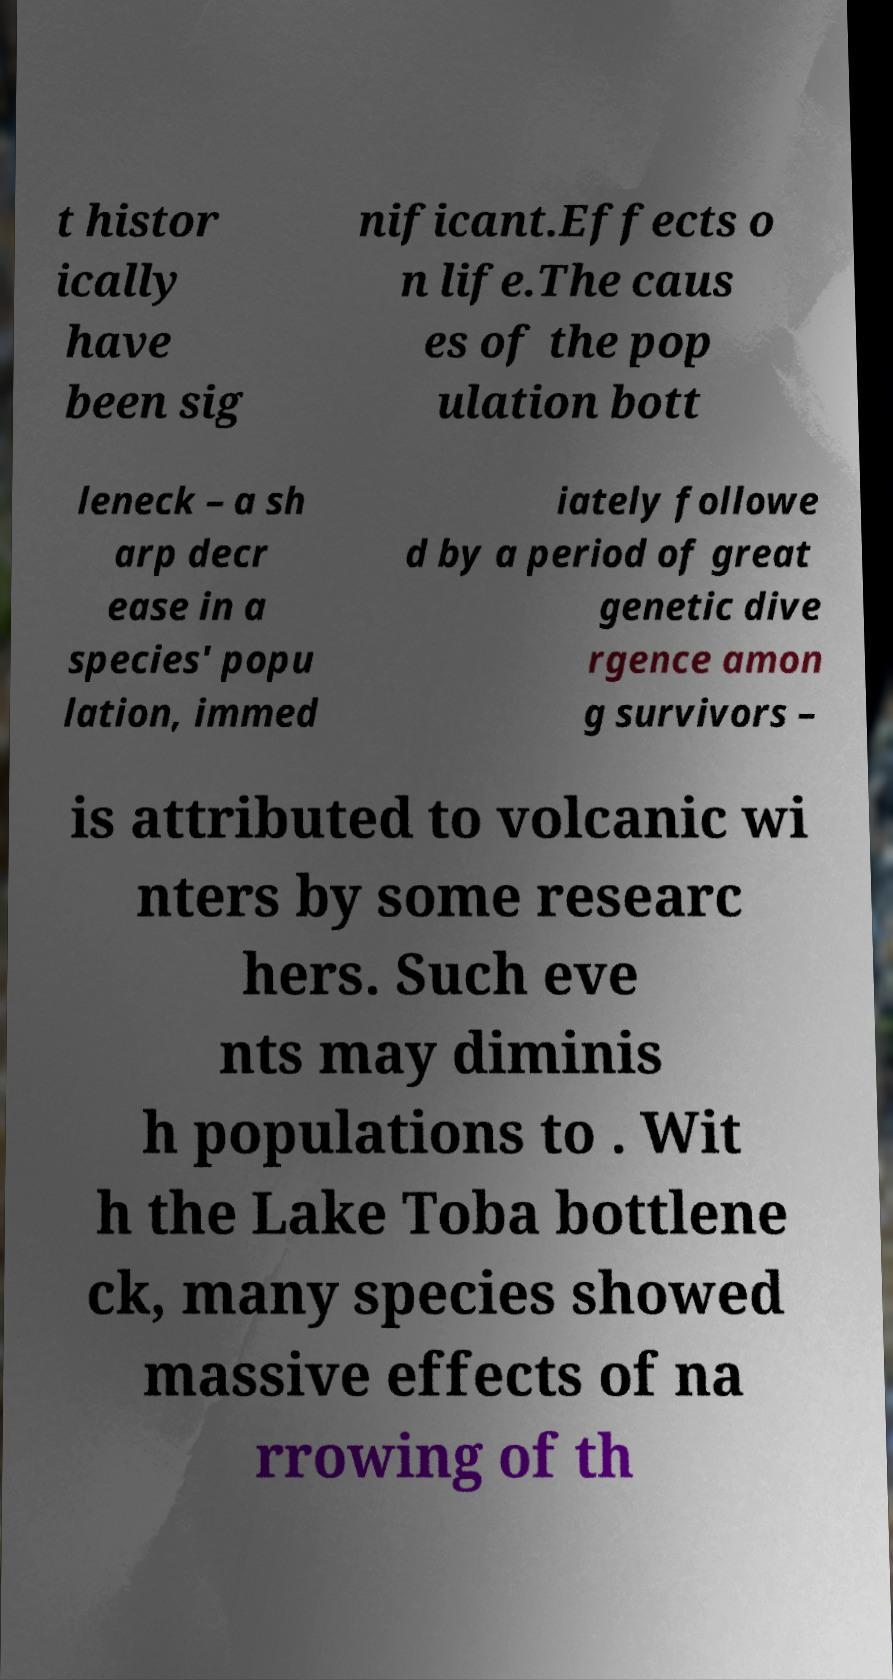For documentation purposes, I need the text within this image transcribed. Could you provide that? t histor ically have been sig nificant.Effects o n life.The caus es of the pop ulation bott leneck – a sh arp decr ease in a species' popu lation, immed iately followe d by a period of great genetic dive rgence amon g survivors – is attributed to volcanic wi nters by some researc hers. Such eve nts may diminis h populations to . Wit h the Lake Toba bottlene ck, many species showed massive effects of na rrowing of th 